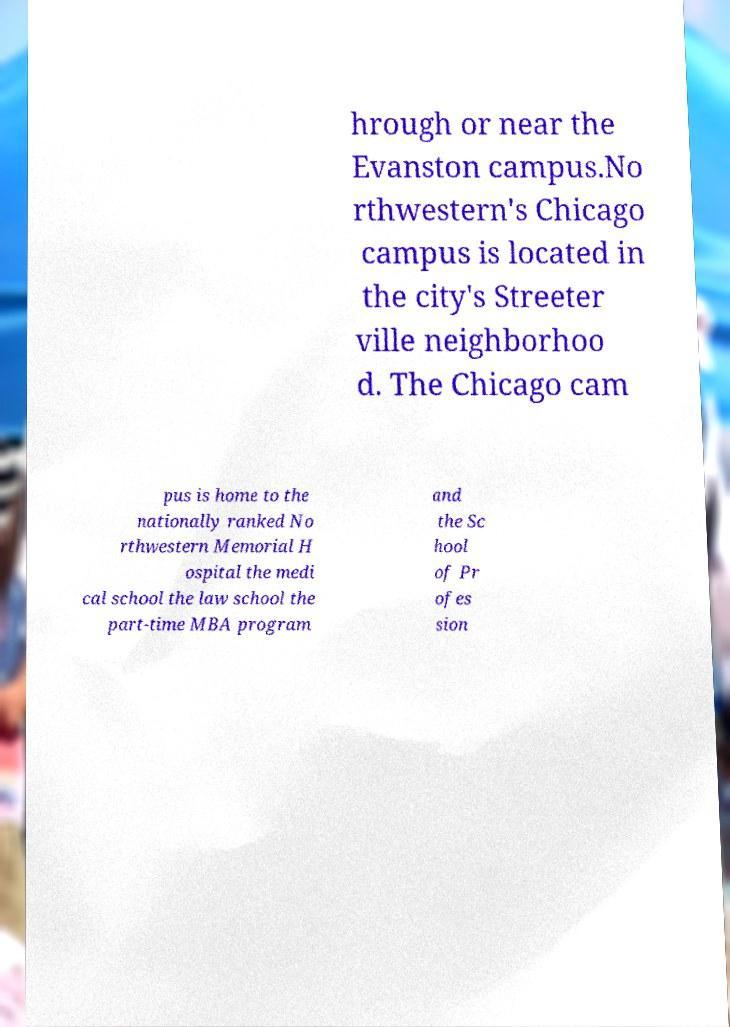What messages or text are displayed in this image? I need them in a readable, typed format. hrough or near the Evanston campus.No rthwestern's Chicago campus is located in the city's Streeter ville neighborhoo d. The Chicago cam pus is home to the nationally ranked No rthwestern Memorial H ospital the medi cal school the law school the part-time MBA program and the Sc hool of Pr ofes sion 